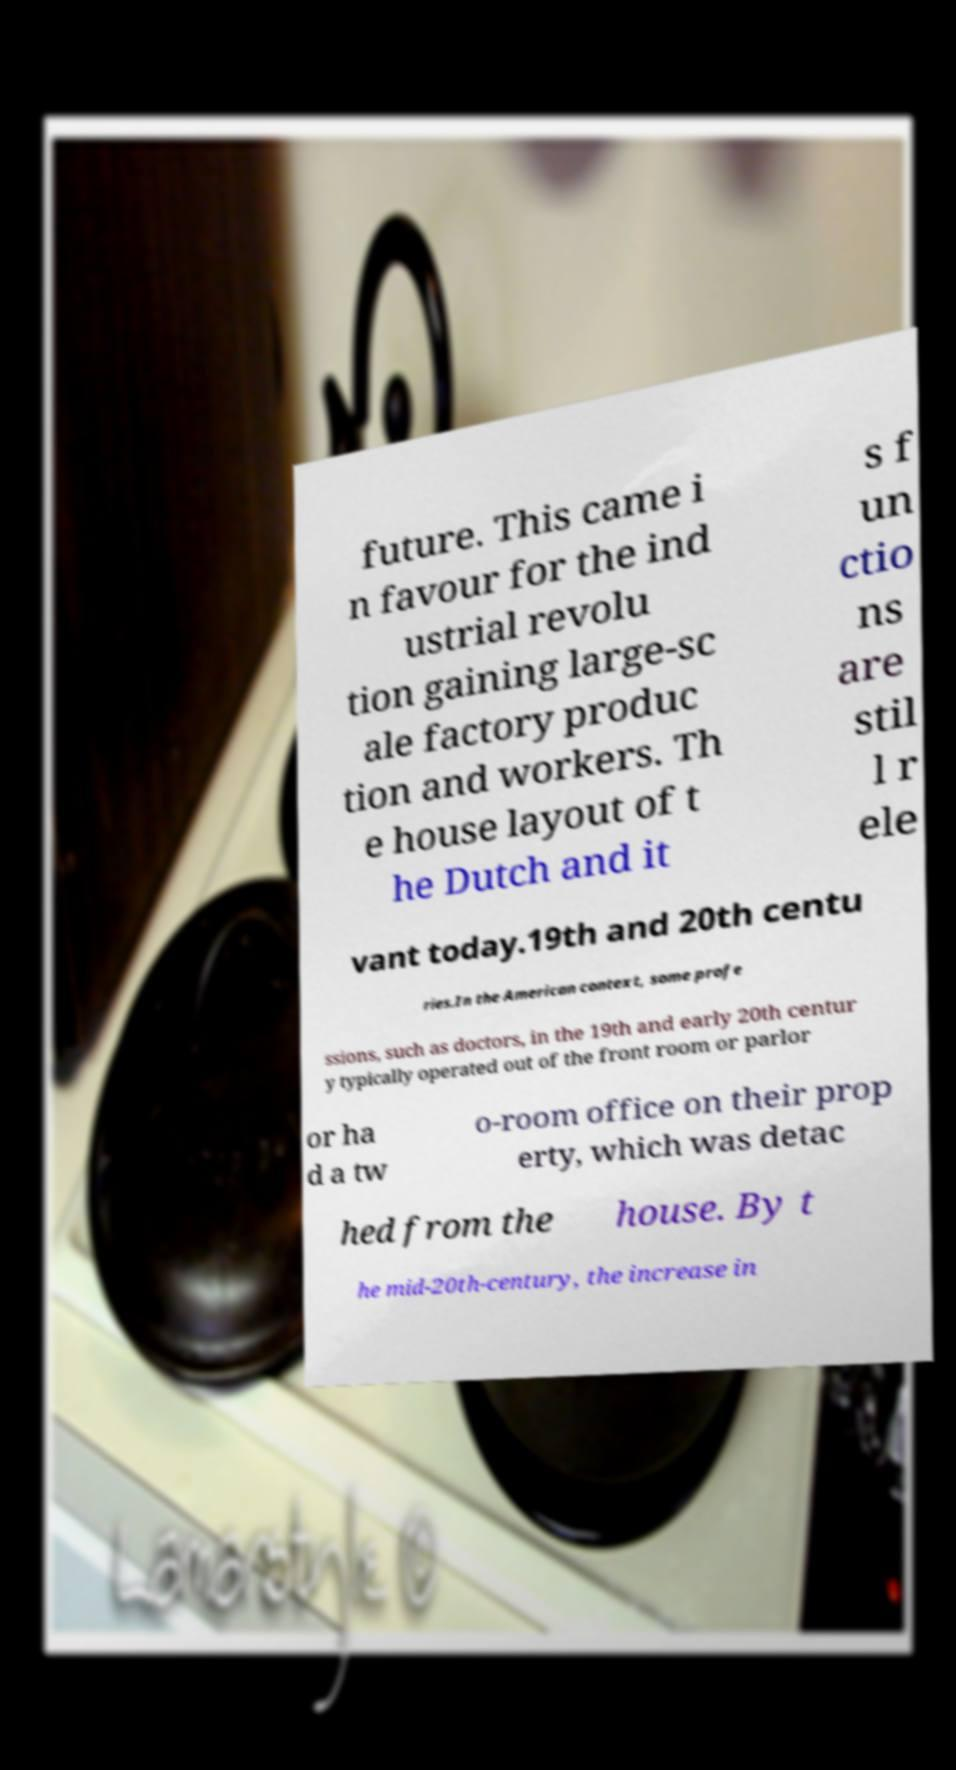What messages or text are displayed in this image? I need them in a readable, typed format. future. This came i n favour for the ind ustrial revolu tion gaining large-sc ale factory produc tion and workers. Th e house layout of t he Dutch and it s f un ctio ns are stil l r ele vant today.19th and 20th centu ries.In the American context, some profe ssions, such as doctors, in the 19th and early 20th centur y typically operated out of the front room or parlor or ha d a tw o-room office on their prop erty, which was detac hed from the house. By t he mid-20th-century, the increase in 